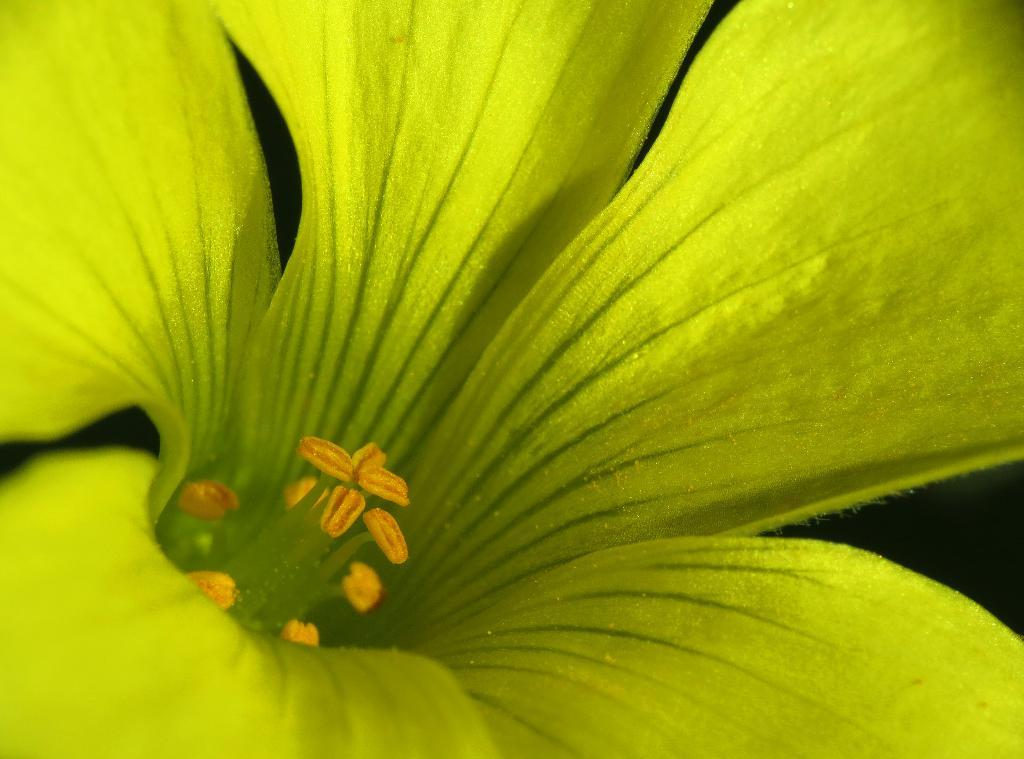What is the main subject of the image? There is a flower in the center of the image. What color is the flower? The flower is green in color. How many steps are required to reach the flower in the image? There is no indication of steps or a path in the image, so it is not possible to determine the number of steps required to reach the flower. 